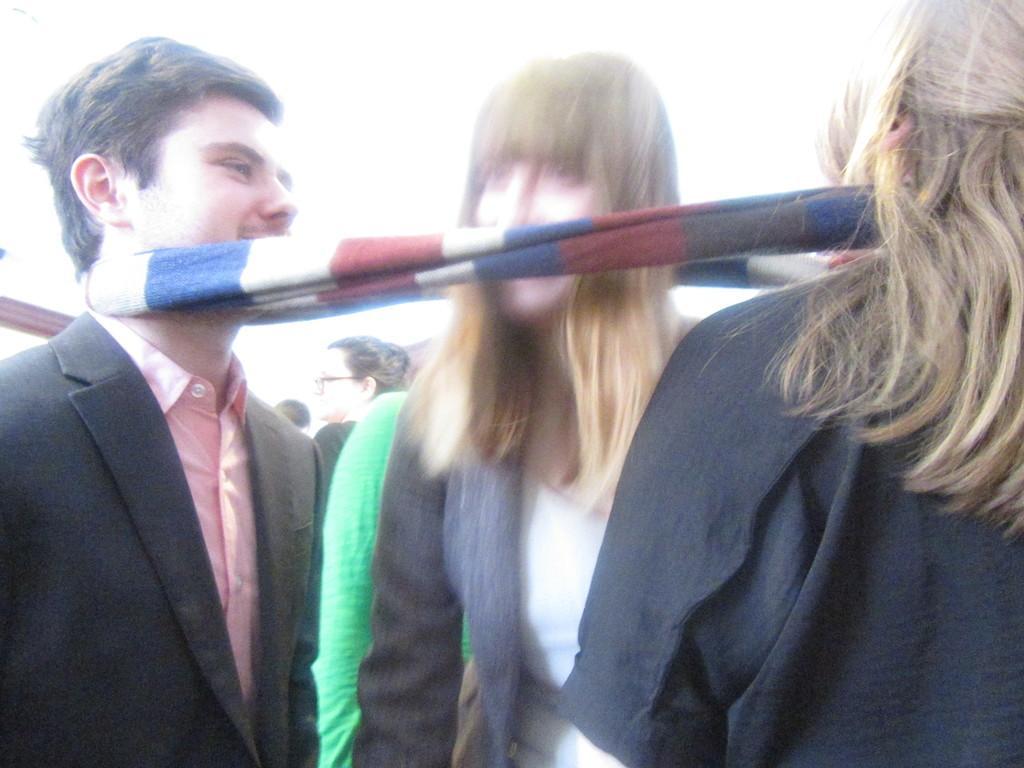Can you describe this image briefly? This image consists of three persons. On the left, the man is wearing a black suit. On the right, the woman is wearing a black dress. In the middle, there is another woman. And these three persons are tied with a scarf. At the top, there is sky. 